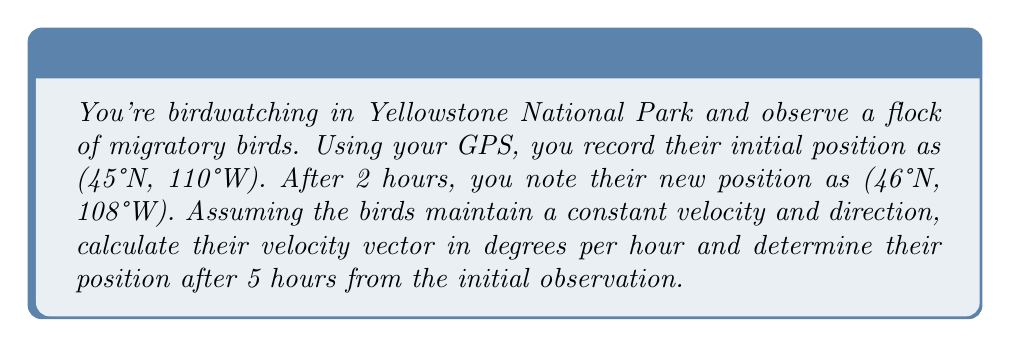Can you solve this math problem? To solve this problem, we'll use vector mathematics to analyze the birds' migration pattern.

1. Convert the positions to vector notation:
   Initial position: $\vec{r_1} = (45, -110)$
   Position after 2 hours: $\vec{r_2} = (46, -108)$

2. Calculate the displacement vector:
   $\vec{\Delta r} = \vec{r_2} - \vec{r_1} = (46, -108) - (45, -110) = (1, 2)$

3. Calculate the velocity vector:
   $\vec{v} = \frac{\vec{\Delta r}}{\Delta t} = \frac{(1, 2)}{2} = (0.5, 1)$ degrees per hour

4. Convert the velocity vector to polar coordinates (magnitude and direction):
   Magnitude: $|\vec{v}| = \sqrt{0.5^2 + 1^2} = \sqrt{1.25} \approx 1.118$ degrees per hour
   Direction: $\theta = \tan^{-1}(\frac{1}{0.5}) \approx 63.43°$ from due North

5. To find the position after 5 hours, multiply the velocity vector by 5 and add it to the initial position:
   $\vec{r_3} = \vec{r_1} + 5\vec{v} = (45, -110) + 5(0.5, 1) = (45, -110) + (2.5, 5) = (47.5, -105)$
Answer: The birds' velocity vector is approximately 1.118 degrees per hour at an angle of 63.43° from due North. Their position after 5 hours from the initial observation is (47.5°N, 105°W). 